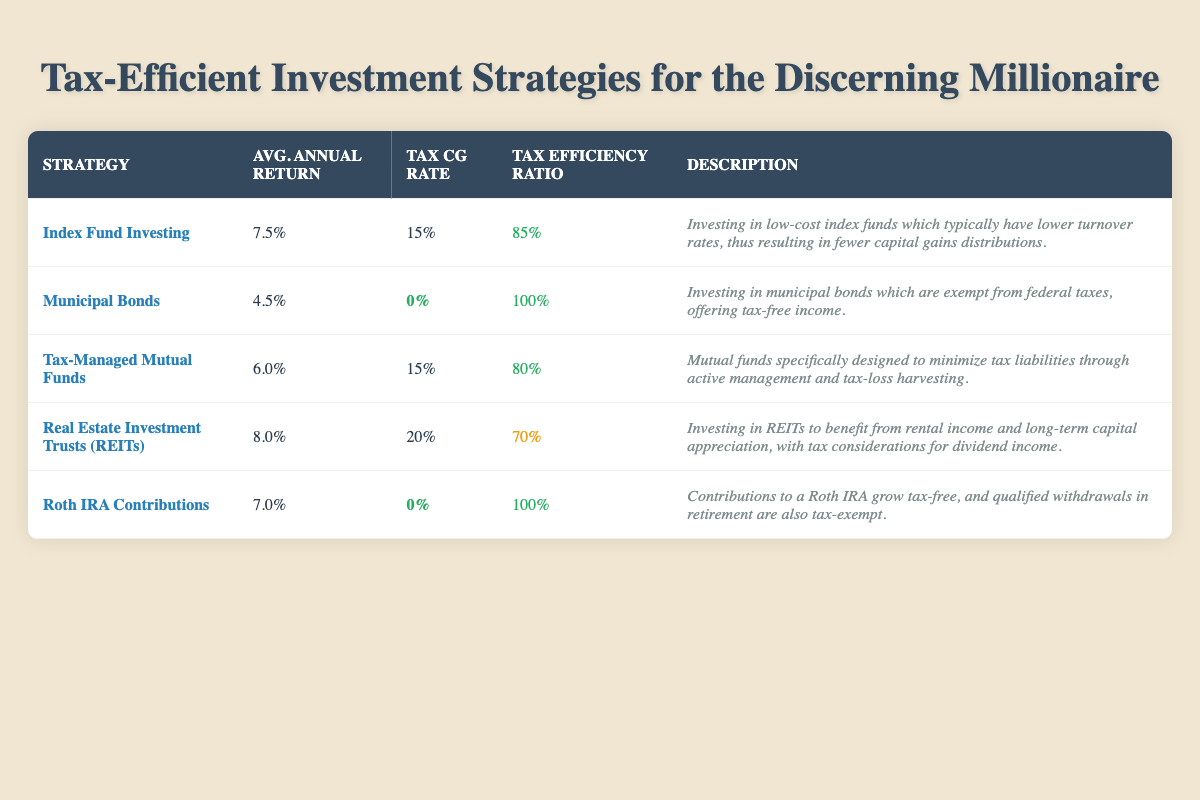What is the average annual return of Tax-Managed Mutual Funds? The table lists the average annual return for Tax-Managed Mutual Funds as 6.0%.
Answer: 6.0% Which strategy has the highest tax efficiency ratio? From the table, both Municipal Bonds and Roth IRA Contributions have the highest tax efficiency ratio of 100%.
Answer: Municipal Bonds and Roth IRA Contributions What is the tax capital gains rate for Real Estate Investment Trusts (REITs)? The table shows that the tax capital gains rate for REITs is 20%.
Answer: 20% If I combine the average annual returns of Index Fund Investing and Roth IRA Contributions, what is the total? Adding the average annual returns, 7.5% (Index Fund) + 7.0% (Roth IRA) equals 14.5%.
Answer: 14.5% Is the tax capital gains rate for Municipal Bonds equal to zero? The table states that the tax capital gains rate for Municipal Bonds is 0%. Thus, the statement is true.
Answer: Yes Which investment strategy offers tax-free income? The description for Municipal Bonds indicates that they offer tax-free income due to being exempt from federal taxes.
Answer: Municipal Bonds Calculate the average tax efficiency ratio of all strategies. The tax efficiency ratios are 85, 100, 80, 70, and 100. Summing them gives 435, and dividing by 5 (the number of strategies) results in 87.
Answer: 87 Does Tax-Managed Mutual Funds have a lower average annual return than Real Estate Investment Trusts (REITs)? The average annual return for Tax-Managed Mutual Funds is 6.0% while for REITs it is 8.0%, which shows that Tax-Managed Mutual Funds has a lower return.
Answer: Yes What is the average annual return of the strategy with the lowest tax efficiency ratio? The strategy with the lowest tax efficiency ratio is Real Estate Investment Trusts (REITs) with an average annual return of 8.0%.
Answer: 8.0% 